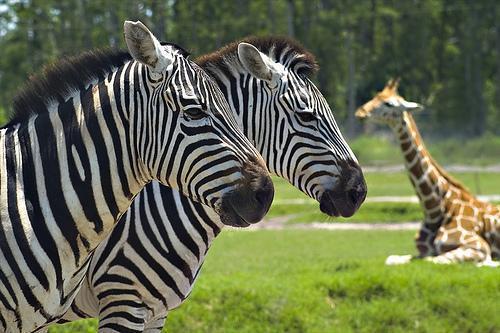How many animals are in the image?
Give a very brief answer. 3. How many zebras are in the picture?
Give a very brief answer. 2. 